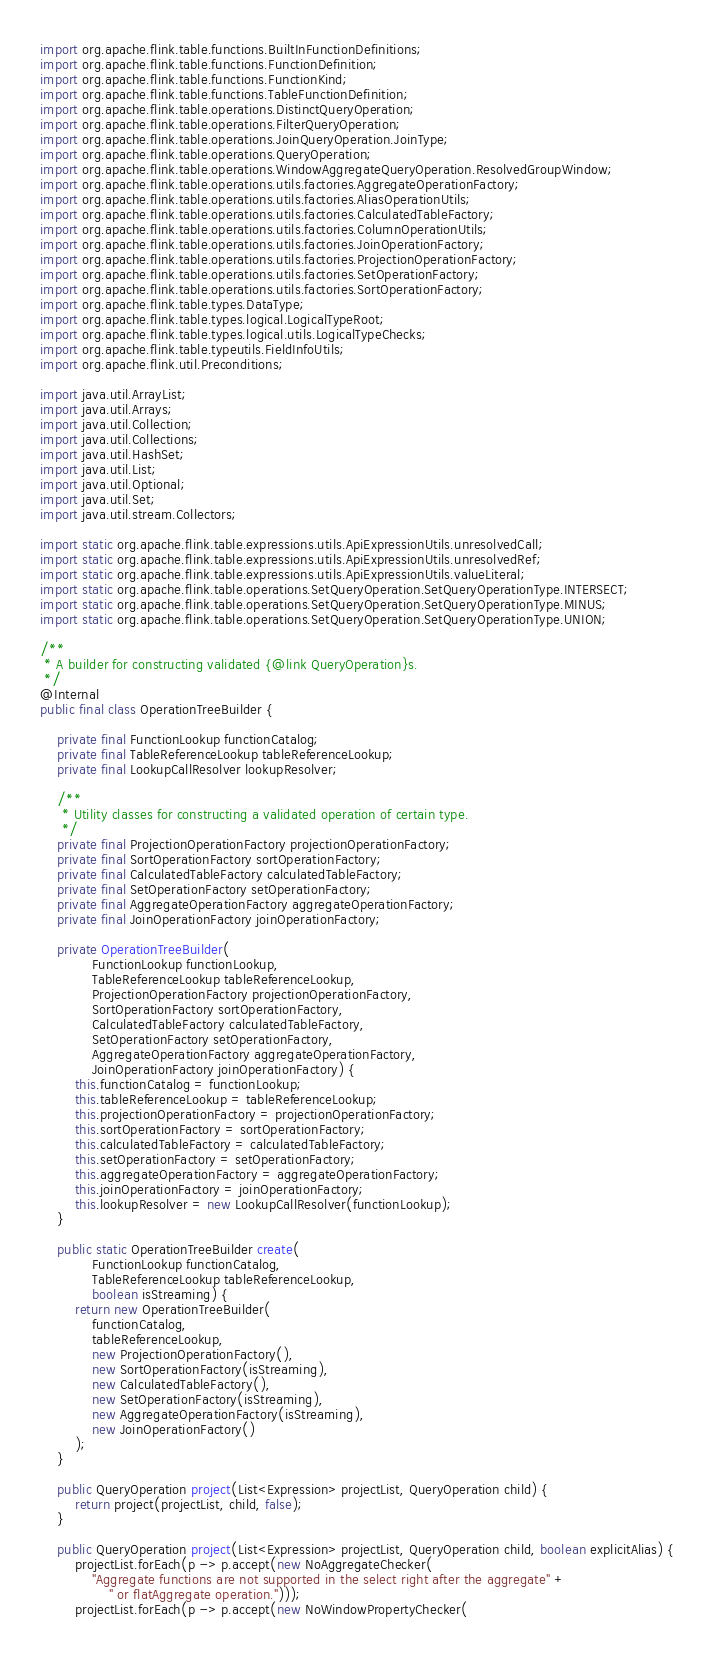<code> <loc_0><loc_0><loc_500><loc_500><_Java_>import org.apache.flink.table.functions.BuiltInFunctionDefinitions;
import org.apache.flink.table.functions.FunctionDefinition;
import org.apache.flink.table.functions.FunctionKind;
import org.apache.flink.table.functions.TableFunctionDefinition;
import org.apache.flink.table.operations.DistinctQueryOperation;
import org.apache.flink.table.operations.FilterQueryOperation;
import org.apache.flink.table.operations.JoinQueryOperation.JoinType;
import org.apache.flink.table.operations.QueryOperation;
import org.apache.flink.table.operations.WindowAggregateQueryOperation.ResolvedGroupWindow;
import org.apache.flink.table.operations.utils.factories.AggregateOperationFactory;
import org.apache.flink.table.operations.utils.factories.AliasOperationUtils;
import org.apache.flink.table.operations.utils.factories.CalculatedTableFactory;
import org.apache.flink.table.operations.utils.factories.ColumnOperationUtils;
import org.apache.flink.table.operations.utils.factories.JoinOperationFactory;
import org.apache.flink.table.operations.utils.factories.ProjectionOperationFactory;
import org.apache.flink.table.operations.utils.factories.SetOperationFactory;
import org.apache.flink.table.operations.utils.factories.SortOperationFactory;
import org.apache.flink.table.types.DataType;
import org.apache.flink.table.types.logical.LogicalTypeRoot;
import org.apache.flink.table.types.logical.utils.LogicalTypeChecks;
import org.apache.flink.table.typeutils.FieldInfoUtils;
import org.apache.flink.util.Preconditions;

import java.util.ArrayList;
import java.util.Arrays;
import java.util.Collection;
import java.util.Collections;
import java.util.HashSet;
import java.util.List;
import java.util.Optional;
import java.util.Set;
import java.util.stream.Collectors;

import static org.apache.flink.table.expressions.utils.ApiExpressionUtils.unresolvedCall;
import static org.apache.flink.table.expressions.utils.ApiExpressionUtils.unresolvedRef;
import static org.apache.flink.table.expressions.utils.ApiExpressionUtils.valueLiteral;
import static org.apache.flink.table.operations.SetQueryOperation.SetQueryOperationType.INTERSECT;
import static org.apache.flink.table.operations.SetQueryOperation.SetQueryOperationType.MINUS;
import static org.apache.flink.table.operations.SetQueryOperation.SetQueryOperationType.UNION;

/**
 * A builder for constructing validated {@link QueryOperation}s.
 */
@Internal
public final class OperationTreeBuilder {

	private final FunctionLookup functionCatalog;
	private final TableReferenceLookup tableReferenceLookup;
	private final LookupCallResolver lookupResolver;

	/**
	 * Utility classes for constructing a validated operation of certain type.
	 */
	private final ProjectionOperationFactory projectionOperationFactory;
	private final SortOperationFactory sortOperationFactory;
	private final CalculatedTableFactory calculatedTableFactory;
	private final SetOperationFactory setOperationFactory;
	private final AggregateOperationFactory aggregateOperationFactory;
	private final JoinOperationFactory joinOperationFactory;

	private OperationTreeBuilder(
			FunctionLookup functionLookup,
			TableReferenceLookup tableReferenceLookup,
			ProjectionOperationFactory projectionOperationFactory,
			SortOperationFactory sortOperationFactory,
			CalculatedTableFactory calculatedTableFactory,
			SetOperationFactory setOperationFactory,
			AggregateOperationFactory aggregateOperationFactory,
			JoinOperationFactory joinOperationFactory) {
		this.functionCatalog = functionLookup;
		this.tableReferenceLookup = tableReferenceLookup;
		this.projectionOperationFactory = projectionOperationFactory;
		this.sortOperationFactory = sortOperationFactory;
		this.calculatedTableFactory = calculatedTableFactory;
		this.setOperationFactory = setOperationFactory;
		this.aggregateOperationFactory = aggregateOperationFactory;
		this.joinOperationFactory = joinOperationFactory;
		this.lookupResolver = new LookupCallResolver(functionLookup);
	}

	public static OperationTreeBuilder create(
			FunctionLookup functionCatalog,
			TableReferenceLookup tableReferenceLookup,
			boolean isStreaming) {
		return new OperationTreeBuilder(
			functionCatalog,
			tableReferenceLookup,
			new ProjectionOperationFactory(),
			new SortOperationFactory(isStreaming),
			new CalculatedTableFactory(),
			new SetOperationFactory(isStreaming),
			new AggregateOperationFactory(isStreaming),
			new JoinOperationFactory()
		);
	}

	public QueryOperation project(List<Expression> projectList, QueryOperation child) {
		return project(projectList, child, false);
	}

	public QueryOperation project(List<Expression> projectList, QueryOperation child, boolean explicitAlias) {
		projectList.forEach(p -> p.accept(new NoAggregateChecker(
			"Aggregate functions are not supported in the select right after the aggregate" +
				" or flatAggregate operation.")));
		projectList.forEach(p -> p.accept(new NoWindowPropertyChecker(</code> 